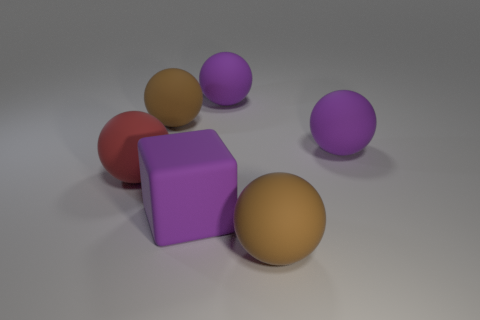There is a big object that is in front of the big purple block; does it have the same color as the large cube to the right of the red rubber sphere?
Your answer should be compact. No. What shape is the large matte thing that is to the left of the purple rubber block and to the right of the red matte sphere?
Keep it short and to the point. Sphere. Are there any small green things of the same shape as the red rubber object?
Your response must be concise. No. What shape is the red object that is the same size as the block?
Provide a succinct answer. Sphere. What material is the purple block?
Your response must be concise. Rubber. There is a purple sphere to the right of the big brown rubber thing that is in front of the brown matte thing that is to the left of the purple rubber block; what is its size?
Provide a short and direct response. Large. How many matte objects are spheres or purple balls?
Keep it short and to the point. 5. The red matte sphere is what size?
Provide a succinct answer. Large. What number of things are big spheres or big purple rubber things that are in front of the big red matte sphere?
Your answer should be compact. 6. What number of other objects are the same color as the matte block?
Offer a very short reply. 2. 